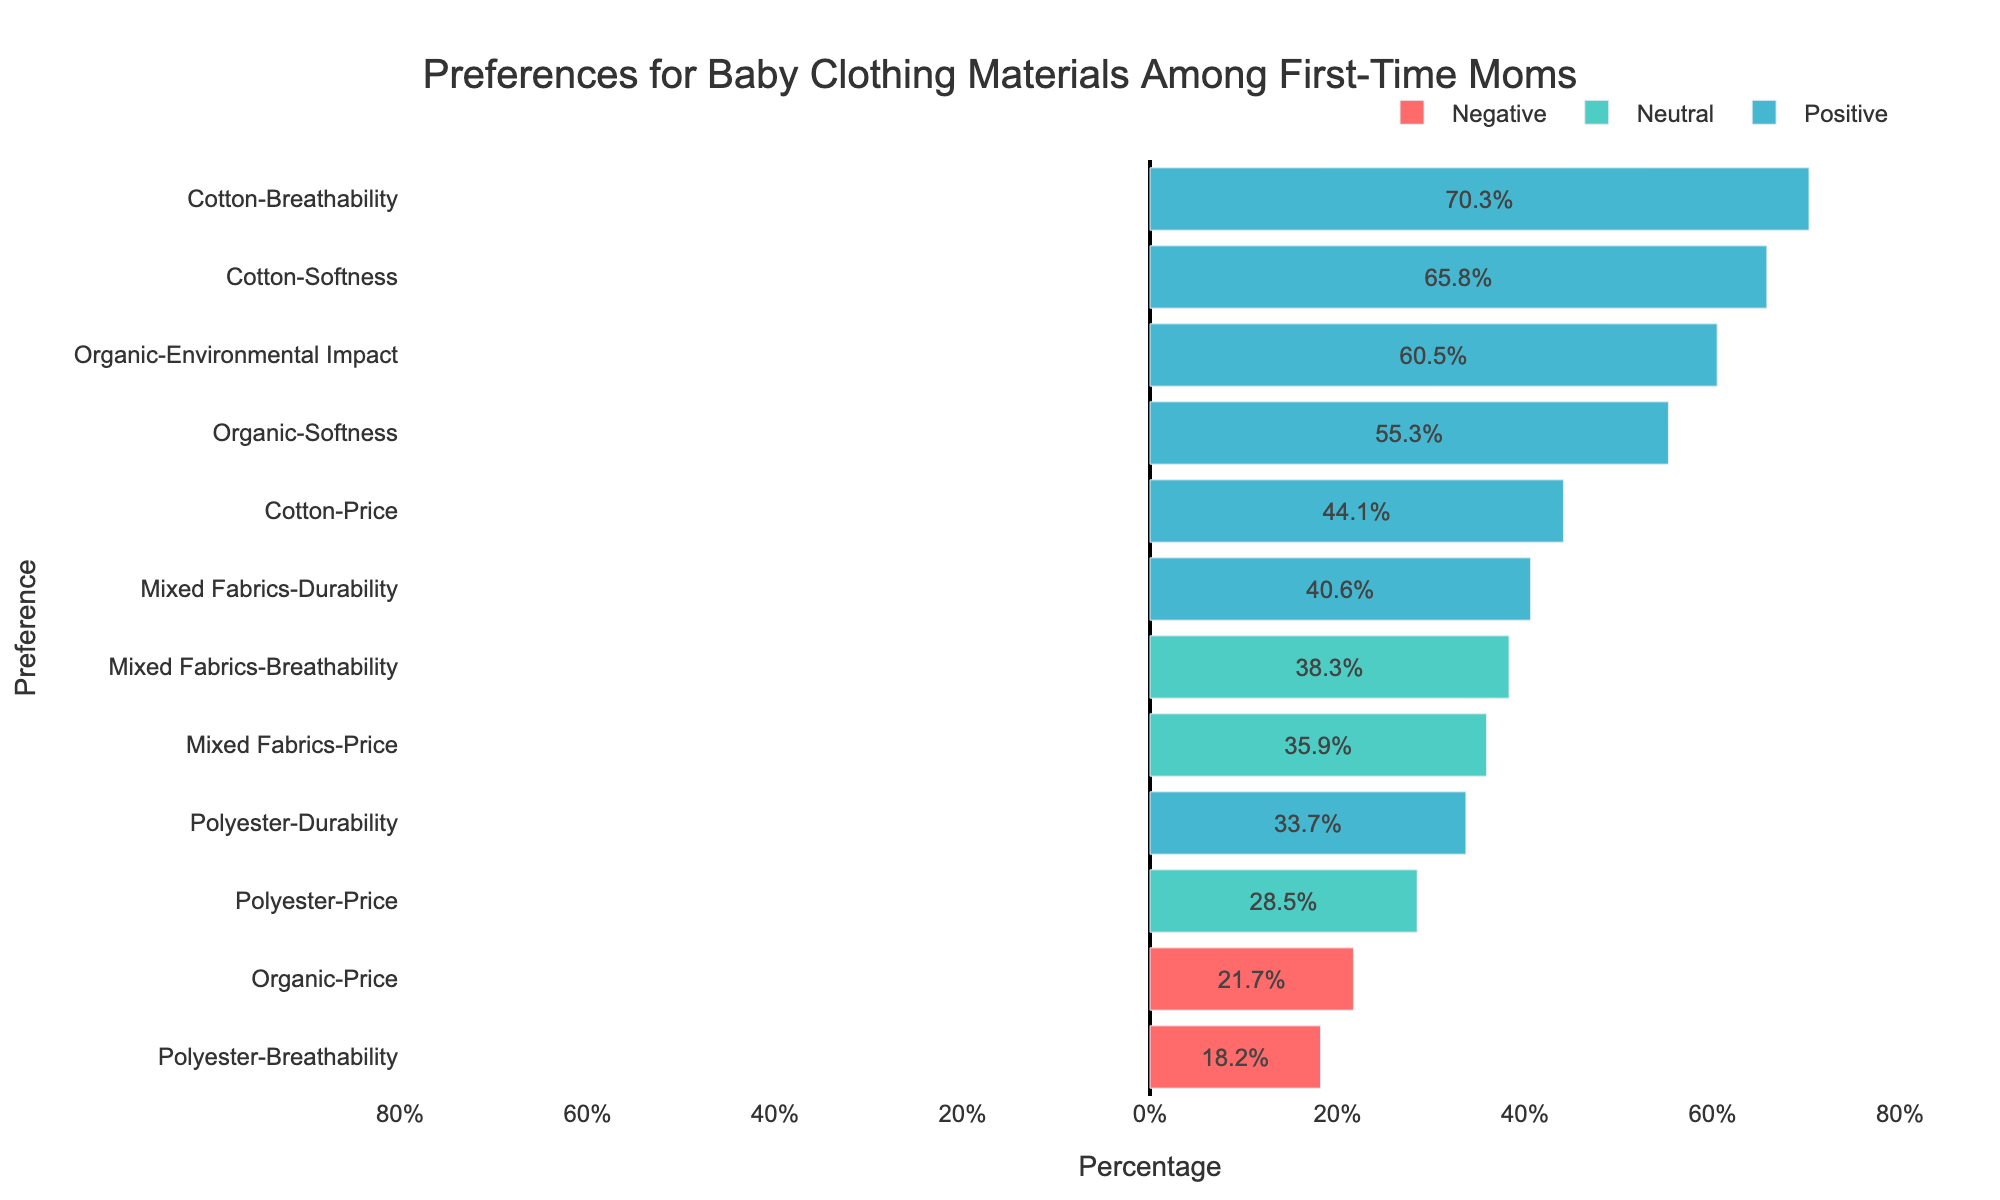What material has the highest preference for breathability? The bar representing "Cotton-Breathability" is the longest in the positive direction, indicating it has the highest percentage for breathability.
Answer: Cotton Which material shows the most negative sentiment for price? The chart shows that "Organic-Price" is the only preference with a bar extending significantly in the negative direction for price.
Answer: Organic Compare the preferences for softness between cotton and organic materials. The bars for "Cotton-Softness" and "Organic-Softness" are both positive, but "Cotton-Softness" has a longer bar, showing a higher percentage.
Answer: Cotton What percentage of first-time moms prefer mixed fabrics for durability? The bar labeled "Mixed Fabrics-Durability" shows a percentage around 40.6%.
Answer: 40.6% Which preference has the lowest percentage of positive sentiment? The shortest positive bar corresponds to "Polyester-Durability," which has a percentage of 33.7%.
Answer: Polyester-Durability What is the total positive percentage for cotton preferences? Adding the percentages for "Cotton-Softness" (65.8), "Cotton-Price" (44.1), and "Cotton-Breathability" (70.3) gives: 65.8 + 44.1 + 70.3 = 180.2.
Answer: 180.2 How does polyester's breathability compare to its durability? The bar for "Polyester-Breathability" is much shorter and in the negative direction, while "Polyester-Durability" is in the positive direction and longer.
Answer: Breathability is worse than durability Which material has the highest preference related to environmental impact? The bar for "Organic-Environmental Impact" is the longest positive bar in its category, indicating the highest preference.
Answer: Organic 